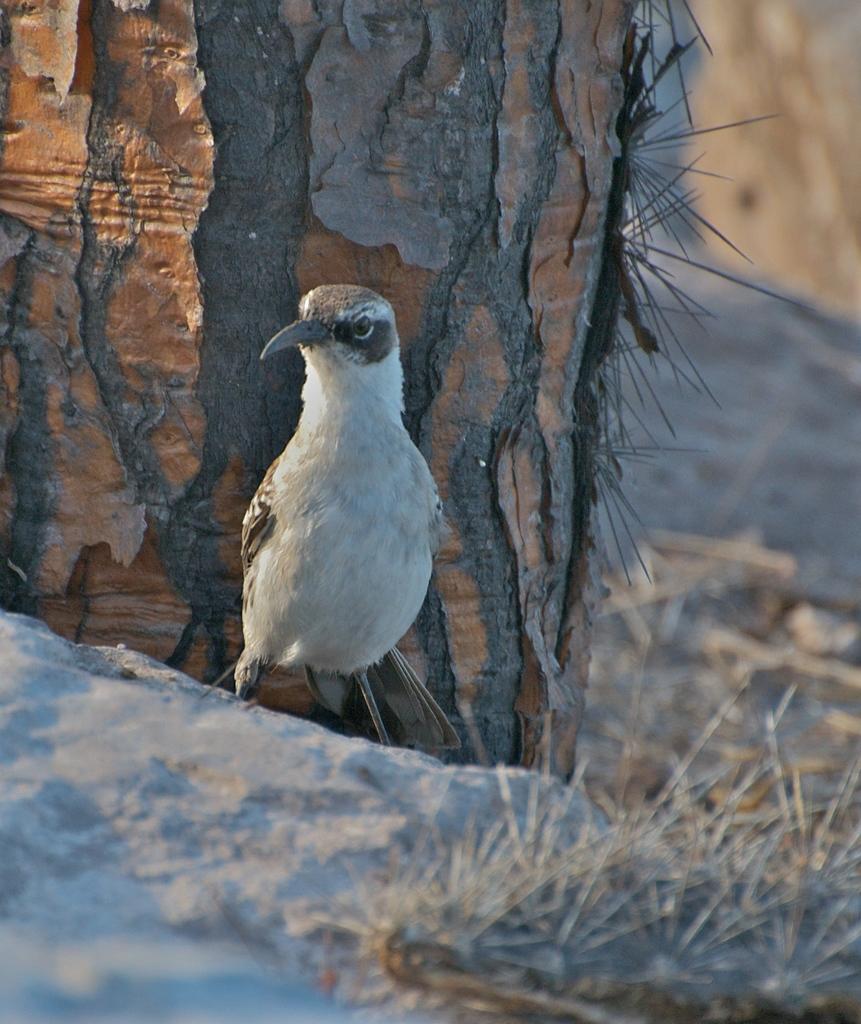Can you describe this image briefly? In the picture I can see a bird is standing on the ground. In the background I can see a tree and the grass. The background of the image is blurred. 